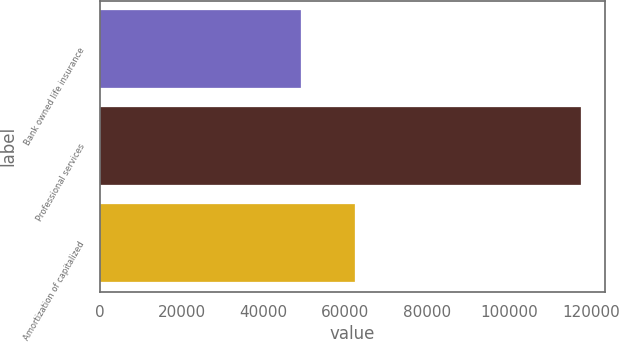Convert chart to OTSL. <chart><loc_0><loc_0><loc_500><loc_500><bar_chart><fcel>Bank owned life insurance<fcel>Professional services<fcel>Amortization of capitalized<nl><fcel>49152<fcel>117523<fcel>62268<nl></chart> 